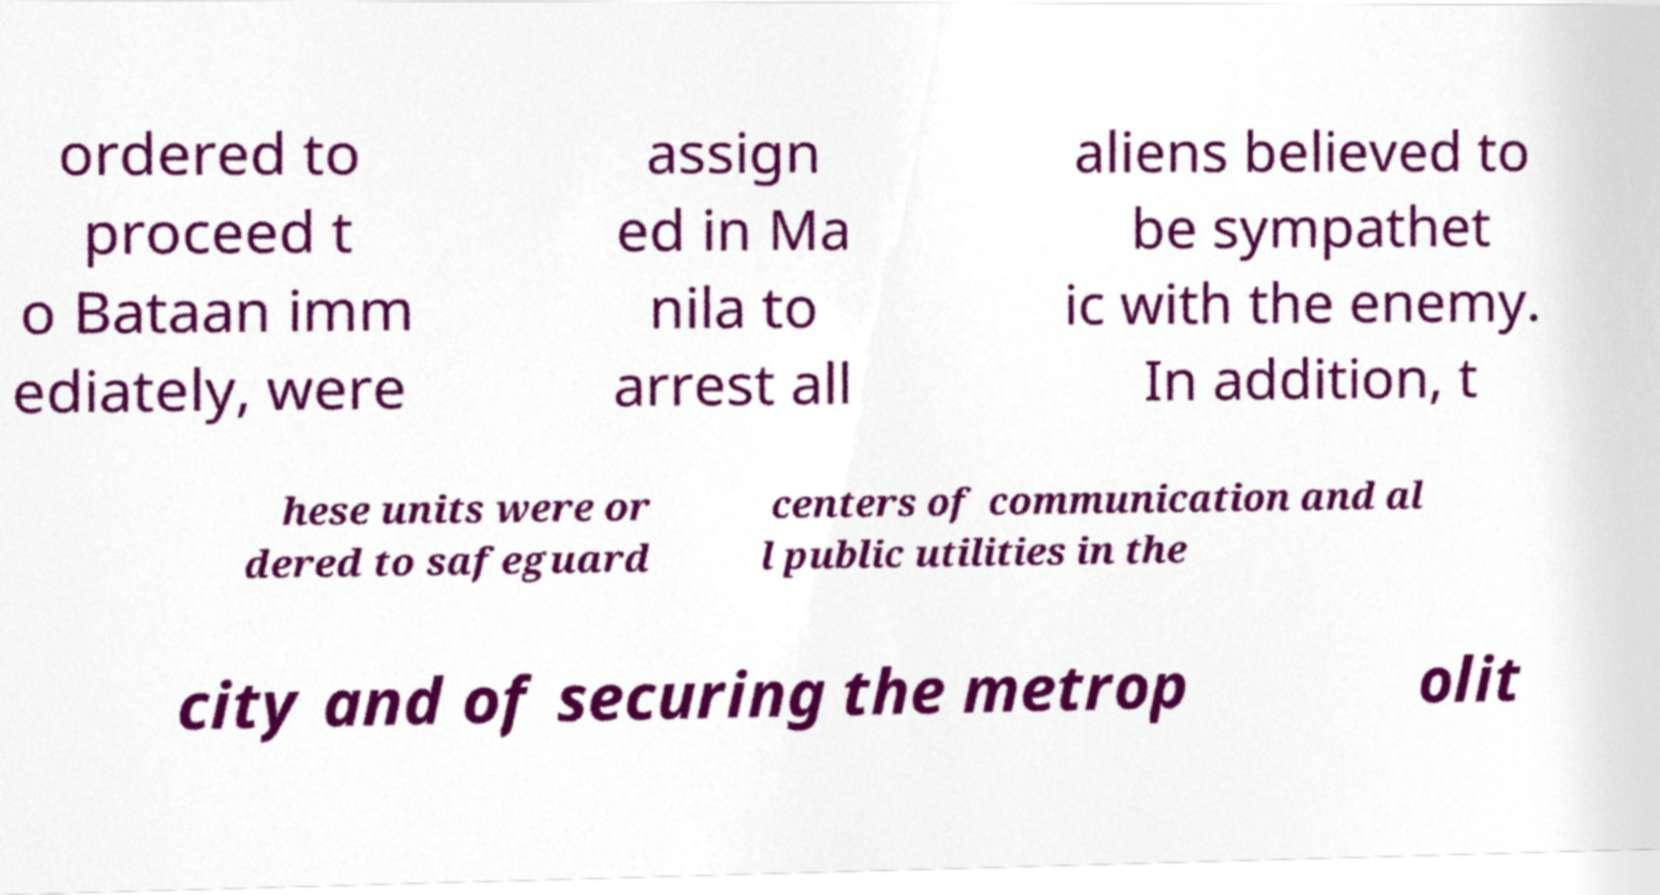Can you read and provide the text displayed in the image?This photo seems to have some interesting text. Can you extract and type it out for me? ordered to proceed t o Bataan imm ediately, were assign ed in Ma nila to arrest all aliens believed to be sympathet ic with the enemy. In addition, t hese units were or dered to safeguard centers of communication and al l public utilities in the city and of securing the metrop olit 